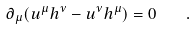<formula> <loc_0><loc_0><loc_500><loc_500>\partial _ { \mu } ( u ^ { \mu } h ^ { \nu } - u ^ { \nu } h ^ { \mu } ) = 0 \quad .</formula> 